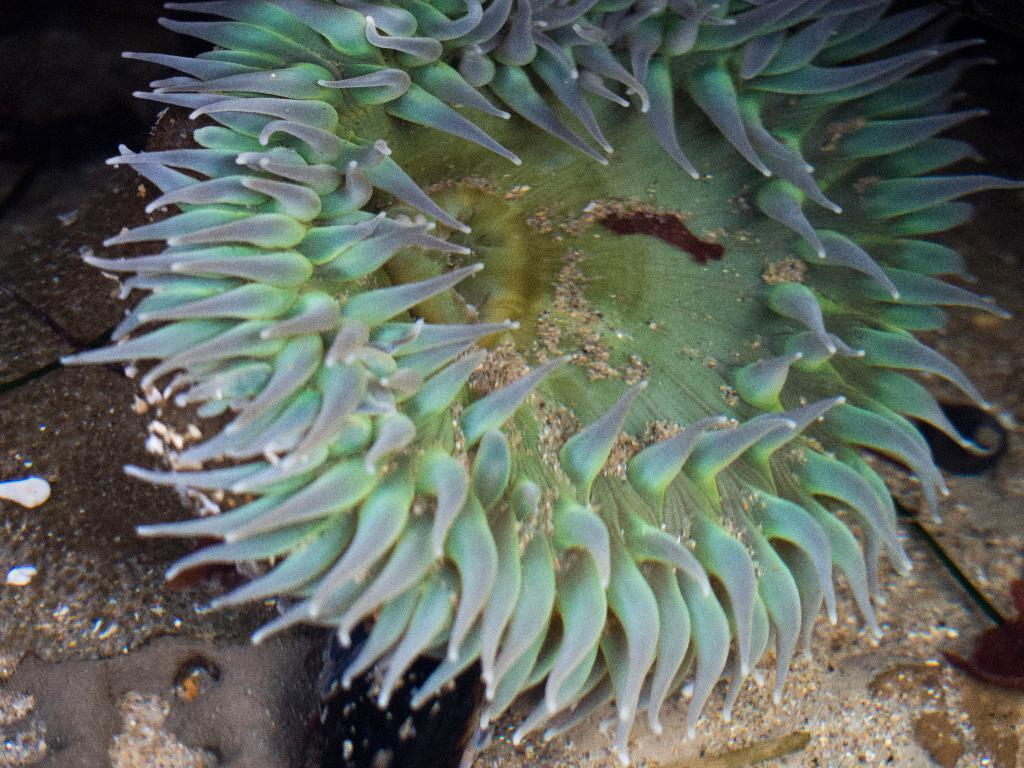What type of environment is depicted in the image? The image shows an underwater marine environment. What can be seen in this underwater environment? There is an underwater marine object in the image. How does the mitten help the marine object in the image? There is no mitten present in the image, as it is an underwater marine environment. 